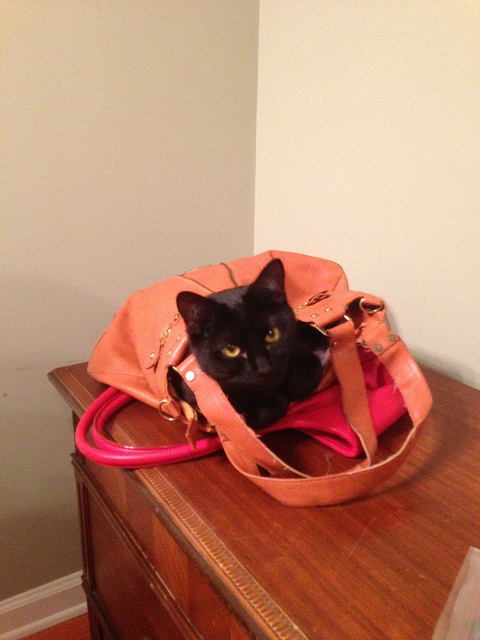Describe the objects in this image and their specific colors. I can see handbag in tan, black, salmon, and brown tones and cat in tan, black, maroon, and brown tones in this image. 